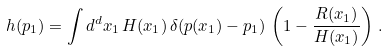Convert formula to latex. <formula><loc_0><loc_0><loc_500><loc_500>h ( p _ { 1 } ) = \int d ^ { d } x _ { 1 } \, H ( x _ { 1 } ) \, \delta ( p ( x _ { 1 } ) - p _ { 1 } ) \, \left ( 1 - \frac { R ( x _ { 1 } ) } { H ( x _ { 1 } ) } \right ) \, .</formula> 